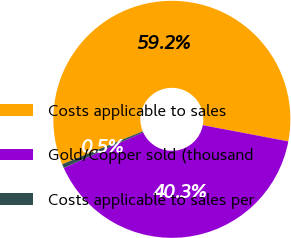Convert chart. <chart><loc_0><loc_0><loc_500><loc_500><pie_chart><fcel>Costs applicable to sales<fcel>Gold/Copper sold (thousand<fcel>Costs applicable to sales per<nl><fcel>59.17%<fcel>40.29%<fcel>0.53%<nl></chart> 